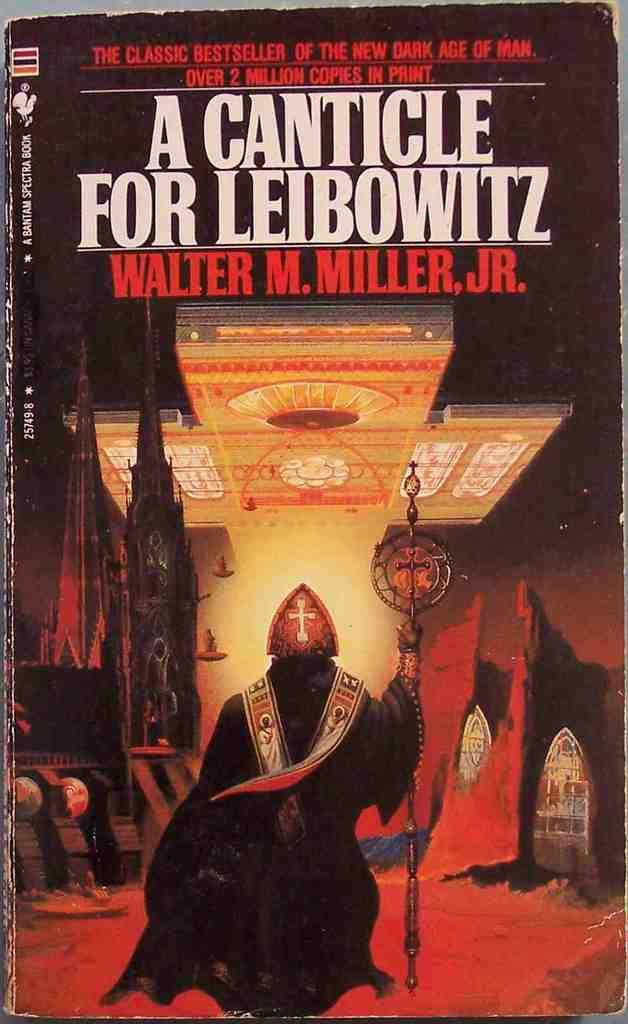<image>
Render a clear and concise summary of the photo. A paperback book written by Walter M. Miller ,Jr is titled A Canticle for Leibowitz. 